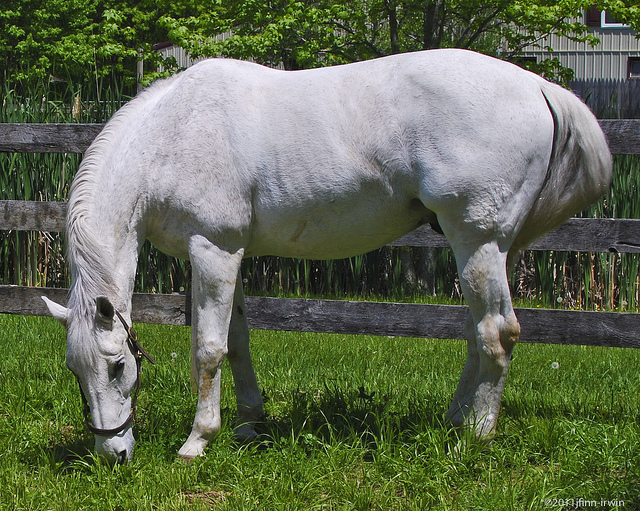If I wanted to introduce another animal into this image, which one would be the most suitable given the context? Given the context of the image, a suitable animal to introduce would be another grazing animal, such as a sheep or a cow. These animals share similar grazing habits and would naturally coexist with a horse in a pasture setting, enhancing the serene and pastoral ambiance of the image. 